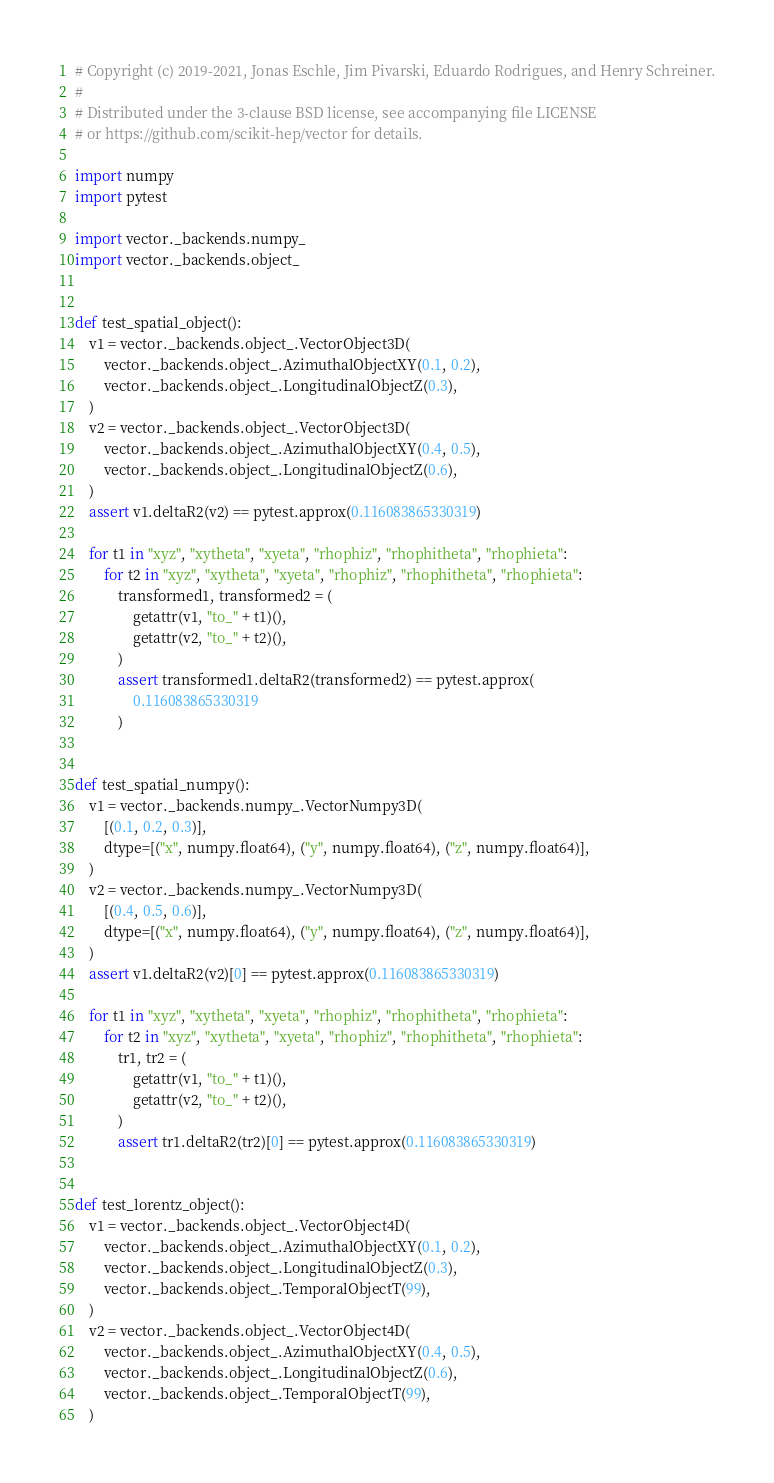Convert code to text. <code><loc_0><loc_0><loc_500><loc_500><_Python_># Copyright (c) 2019-2021, Jonas Eschle, Jim Pivarski, Eduardo Rodrigues, and Henry Schreiner.
#
# Distributed under the 3-clause BSD license, see accompanying file LICENSE
# or https://github.com/scikit-hep/vector for details.

import numpy
import pytest

import vector._backends.numpy_
import vector._backends.object_


def test_spatial_object():
    v1 = vector._backends.object_.VectorObject3D(
        vector._backends.object_.AzimuthalObjectXY(0.1, 0.2),
        vector._backends.object_.LongitudinalObjectZ(0.3),
    )
    v2 = vector._backends.object_.VectorObject3D(
        vector._backends.object_.AzimuthalObjectXY(0.4, 0.5),
        vector._backends.object_.LongitudinalObjectZ(0.6),
    )
    assert v1.deltaR2(v2) == pytest.approx(0.116083865330319)

    for t1 in "xyz", "xytheta", "xyeta", "rhophiz", "rhophitheta", "rhophieta":
        for t2 in "xyz", "xytheta", "xyeta", "rhophiz", "rhophitheta", "rhophieta":
            transformed1, transformed2 = (
                getattr(v1, "to_" + t1)(),
                getattr(v2, "to_" + t2)(),
            )
            assert transformed1.deltaR2(transformed2) == pytest.approx(
                0.116083865330319
            )


def test_spatial_numpy():
    v1 = vector._backends.numpy_.VectorNumpy3D(
        [(0.1, 0.2, 0.3)],
        dtype=[("x", numpy.float64), ("y", numpy.float64), ("z", numpy.float64)],
    )
    v2 = vector._backends.numpy_.VectorNumpy3D(
        [(0.4, 0.5, 0.6)],
        dtype=[("x", numpy.float64), ("y", numpy.float64), ("z", numpy.float64)],
    )
    assert v1.deltaR2(v2)[0] == pytest.approx(0.116083865330319)

    for t1 in "xyz", "xytheta", "xyeta", "rhophiz", "rhophitheta", "rhophieta":
        for t2 in "xyz", "xytheta", "xyeta", "rhophiz", "rhophitheta", "rhophieta":
            tr1, tr2 = (
                getattr(v1, "to_" + t1)(),
                getattr(v2, "to_" + t2)(),
            )
            assert tr1.deltaR2(tr2)[0] == pytest.approx(0.116083865330319)


def test_lorentz_object():
    v1 = vector._backends.object_.VectorObject4D(
        vector._backends.object_.AzimuthalObjectXY(0.1, 0.2),
        vector._backends.object_.LongitudinalObjectZ(0.3),
        vector._backends.object_.TemporalObjectT(99),
    )
    v2 = vector._backends.object_.VectorObject4D(
        vector._backends.object_.AzimuthalObjectXY(0.4, 0.5),
        vector._backends.object_.LongitudinalObjectZ(0.6),
        vector._backends.object_.TemporalObjectT(99),
    )</code> 